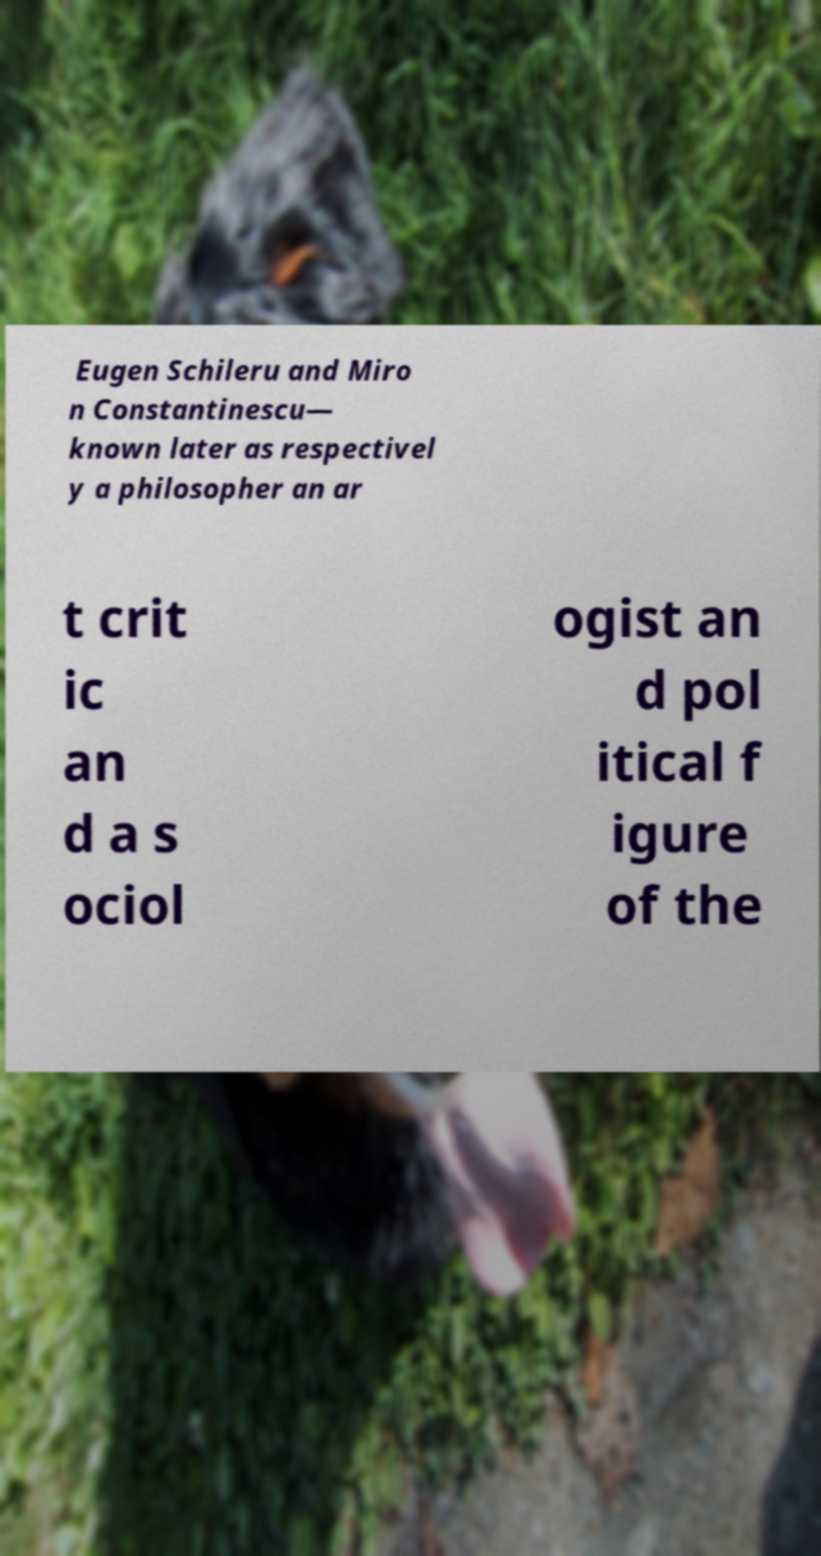I need the written content from this picture converted into text. Can you do that? Eugen Schileru and Miro n Constantinescu— known later as respectivel y a philosopher an ar t crit ic an d a s ociol ogist an d pol itical f igure of the 